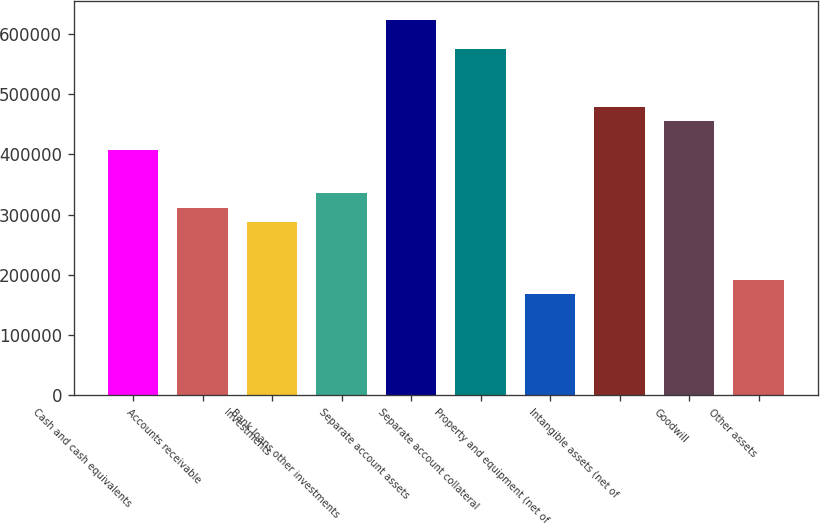Convert chart. <chart><loc_0><loc_0><loc_500><loc_500><bar_chart><fcel>Cash and cash equivalents<fcel>Accounts receivable<fcel>Investments<fcel>Bank loans other investments<fcel>Separate account assets<fcel>Separate account collateral<fcel>Property and equipment (net of<fcel>Intangible assets (net of<fcel>Goodwill<fcel>Other assets<nl><fcel>407672<fcel>311750<fcel>287769<fcel>335730<fcel>623498<fcel>575536<fcel>167866<fcel>479614<fcel>455633<fcel>191847<nl></chart> 